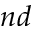<formula> <loc_0><loc_0><loc_500><loc_500>n d</formula> 